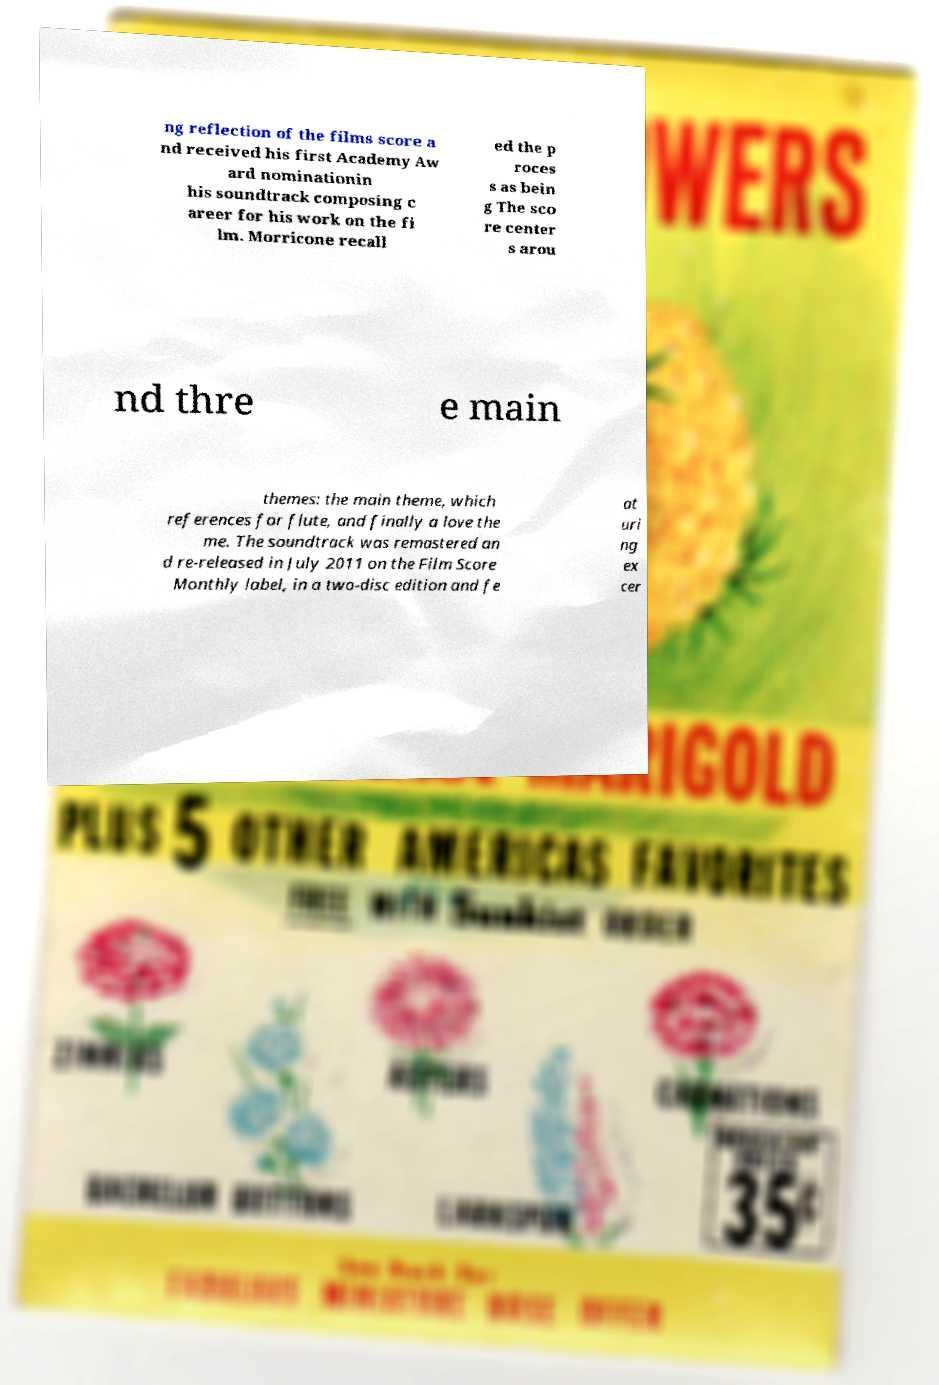Can you read and provide the text displayed in the image?This photo seems to have some interesting text. Can you extract and type it out for me? ng reflection of the films score a nd received his first Academy Aw ard nominationin his soundtrack composing c areer for his work on the fi lm. Morricone recall ed the p roces s as bein g The sco re center s arou nd thre e main themes: the main theme, which references for flute, and finally a love the me. The soundtrack was remastered an d re-released in July 2011 on the Film Score Monthly label, in a two-disc edition and fe at uri ng ex cer 